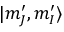<formula> <loc_0><loc_0><loc_500><loc_500>| m _ { J } ^ { \prime } , m _ { I } ^ { \prime } \rangle</formula> 